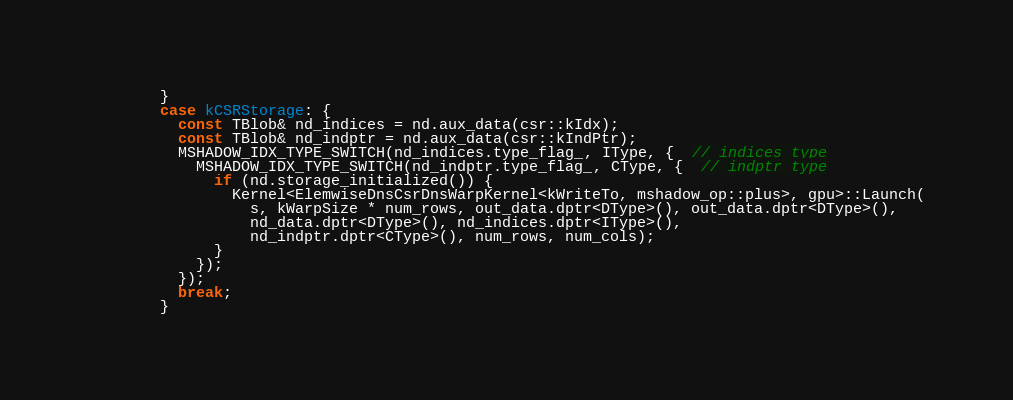<code> <loc_0><loc_0><loc_500><loc_500><_Cuda_>        }
        case kCSRStorage: {
          const TBlob& nd_indices = nd.aux_data(csr::kIdx);
          const TBlob& nd_indptr = nd.aux_data(csr::kIndPtr);
          MSHADOW_IDX_TYPE_SWITCH(nd_indices.type_flag_, IType, {  // indices type
            MSHADOW_IDX_TYPE_SWITCH(nd_indptr.type_flag_, CType, {  // indptr type
              if (nd.storage_initialized()) {
                Kernel<ElemwiseDnsCsrDnsWarpKernel<kWriteTo, mshadow_op::plus>, gpu>::Launch(
                  s, kWarpSize * num_rows, out_data.dptr<DType>(), out_data.dptr<DType>(),
                  nd_data.dptr<DType>(), nd_indices.dptr<IType>(),
                  nd_indptr.dptr<CType>(), num_rows, num_cols);
              }
            });
          });
          break;
        }</code> 